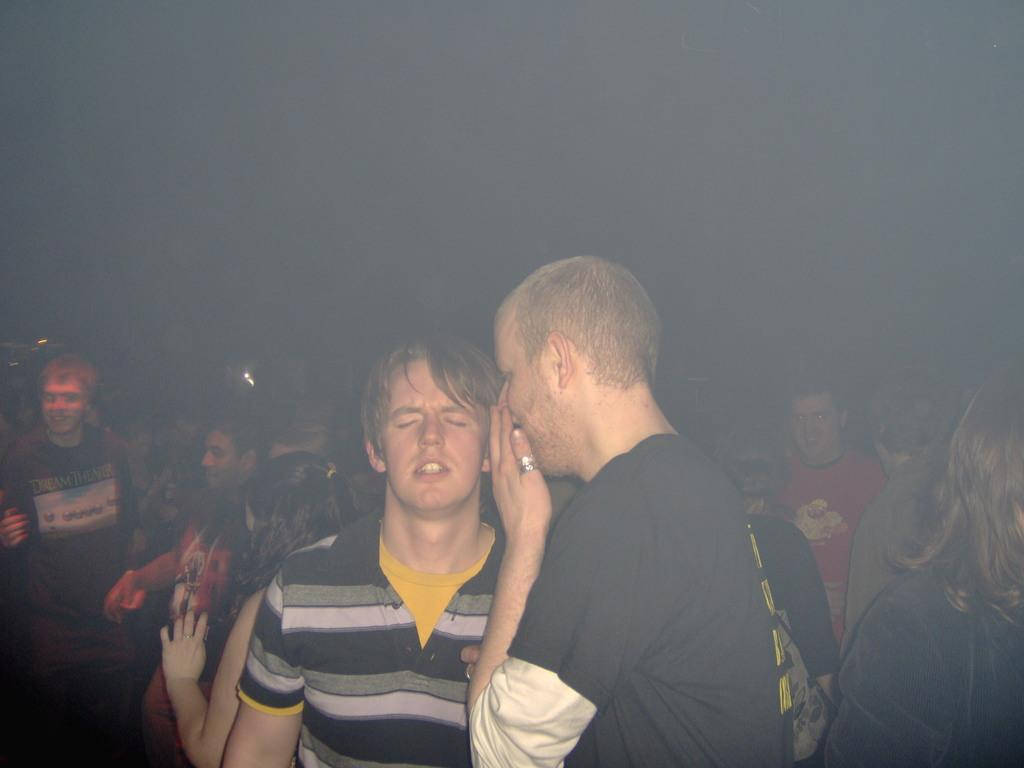How many people are present in the image? There are two persons standing in the image. What can be observed about the background of the image? The background of the image is dark. Can you describe the presence of other people in the image? Yes, there are people visible in the background of the image. What type of wool is being used to attack the cattle in the image? There is no wool, attack, or cattle present in the image. 